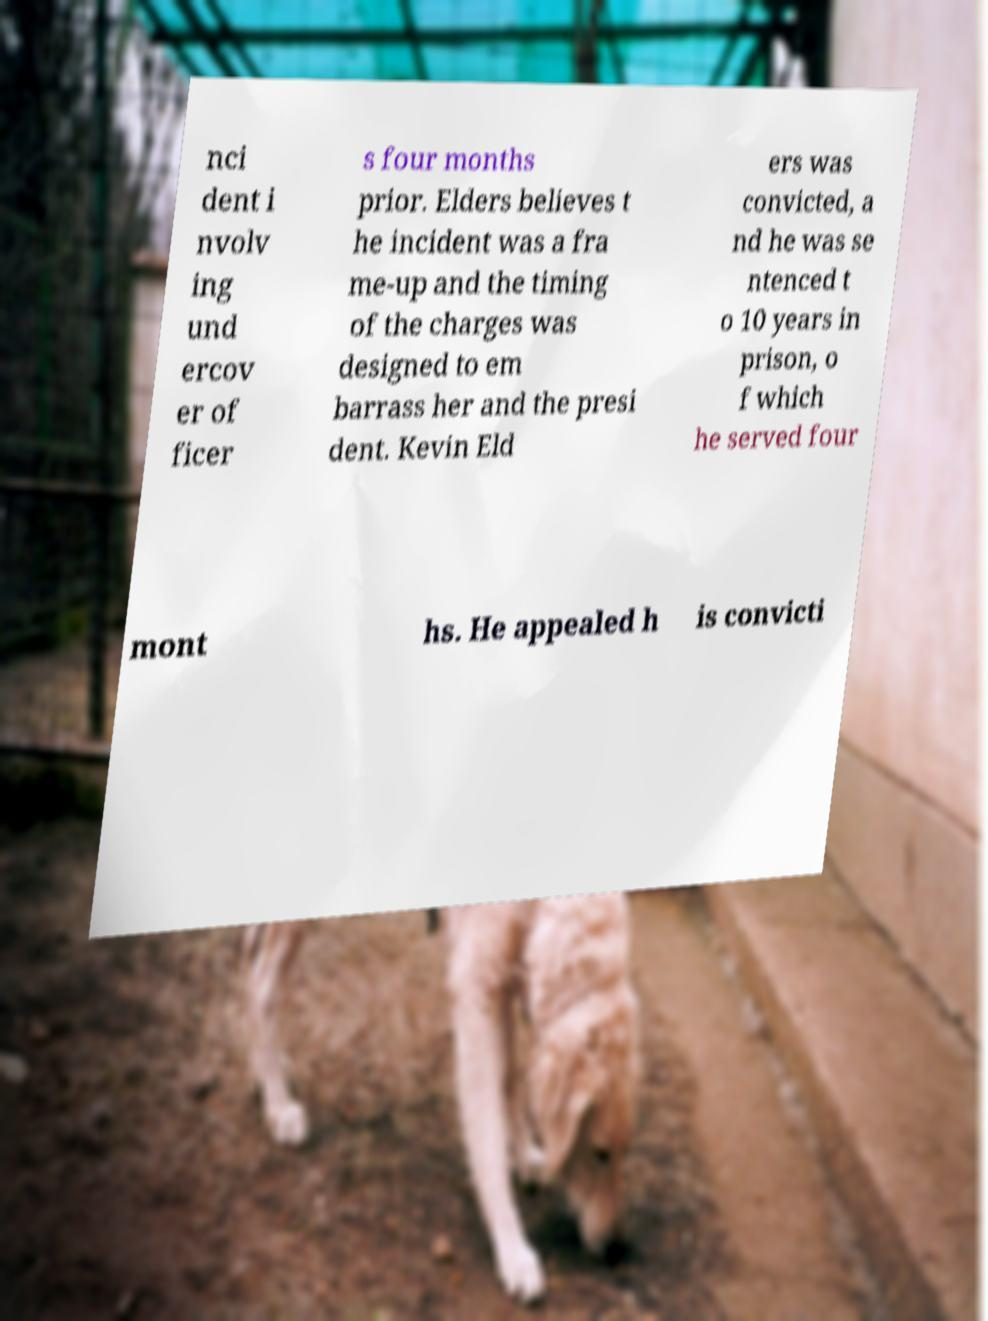I need the written content from this picture converted into text. Can you do that? nci dent i nvolv ing und ercov er of ficer s four months prior. Elders believes t he incident was a fra me-up and the timing of the charges was designed to em barrass her and the presi dent. Kevin Eld ers was convicted, a nd he was se ntenced t o 10 years in prison, o f which he served four mont hs. He appealed h is convicti 